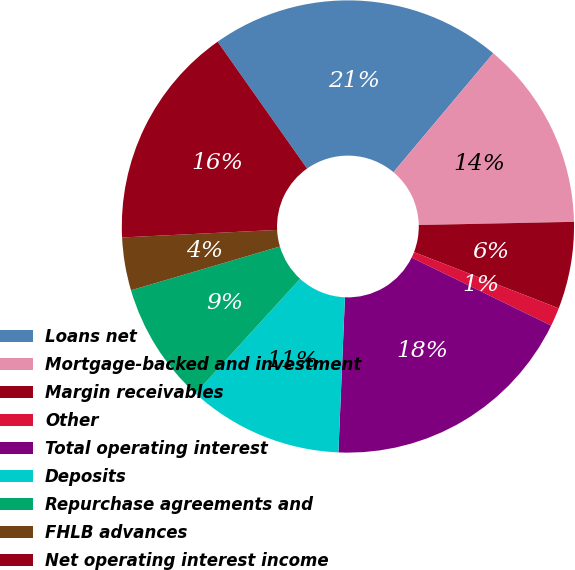Convert chart to OTSL. <chart><loc_0><loc_0><loc_500><loc_500><pie_chart><fcel>Loans net<fcel>Mortgage-backed and investment<fcel>Margin receivables<fcel>Other<fcel>Total operating interest<fcel>Deposits<fcel>Repurchase agreements and<fcel>FHLB advances<fcel>Net operating interest income<nl><fcel>20.89%<fcel>13.56%<fcel>6.22%<fcel>1.33%<fcel>18.45%<fcel>11.11%<fcel>8.67%<fcel>3.78%<fcel>16.0%<nl></chart> 